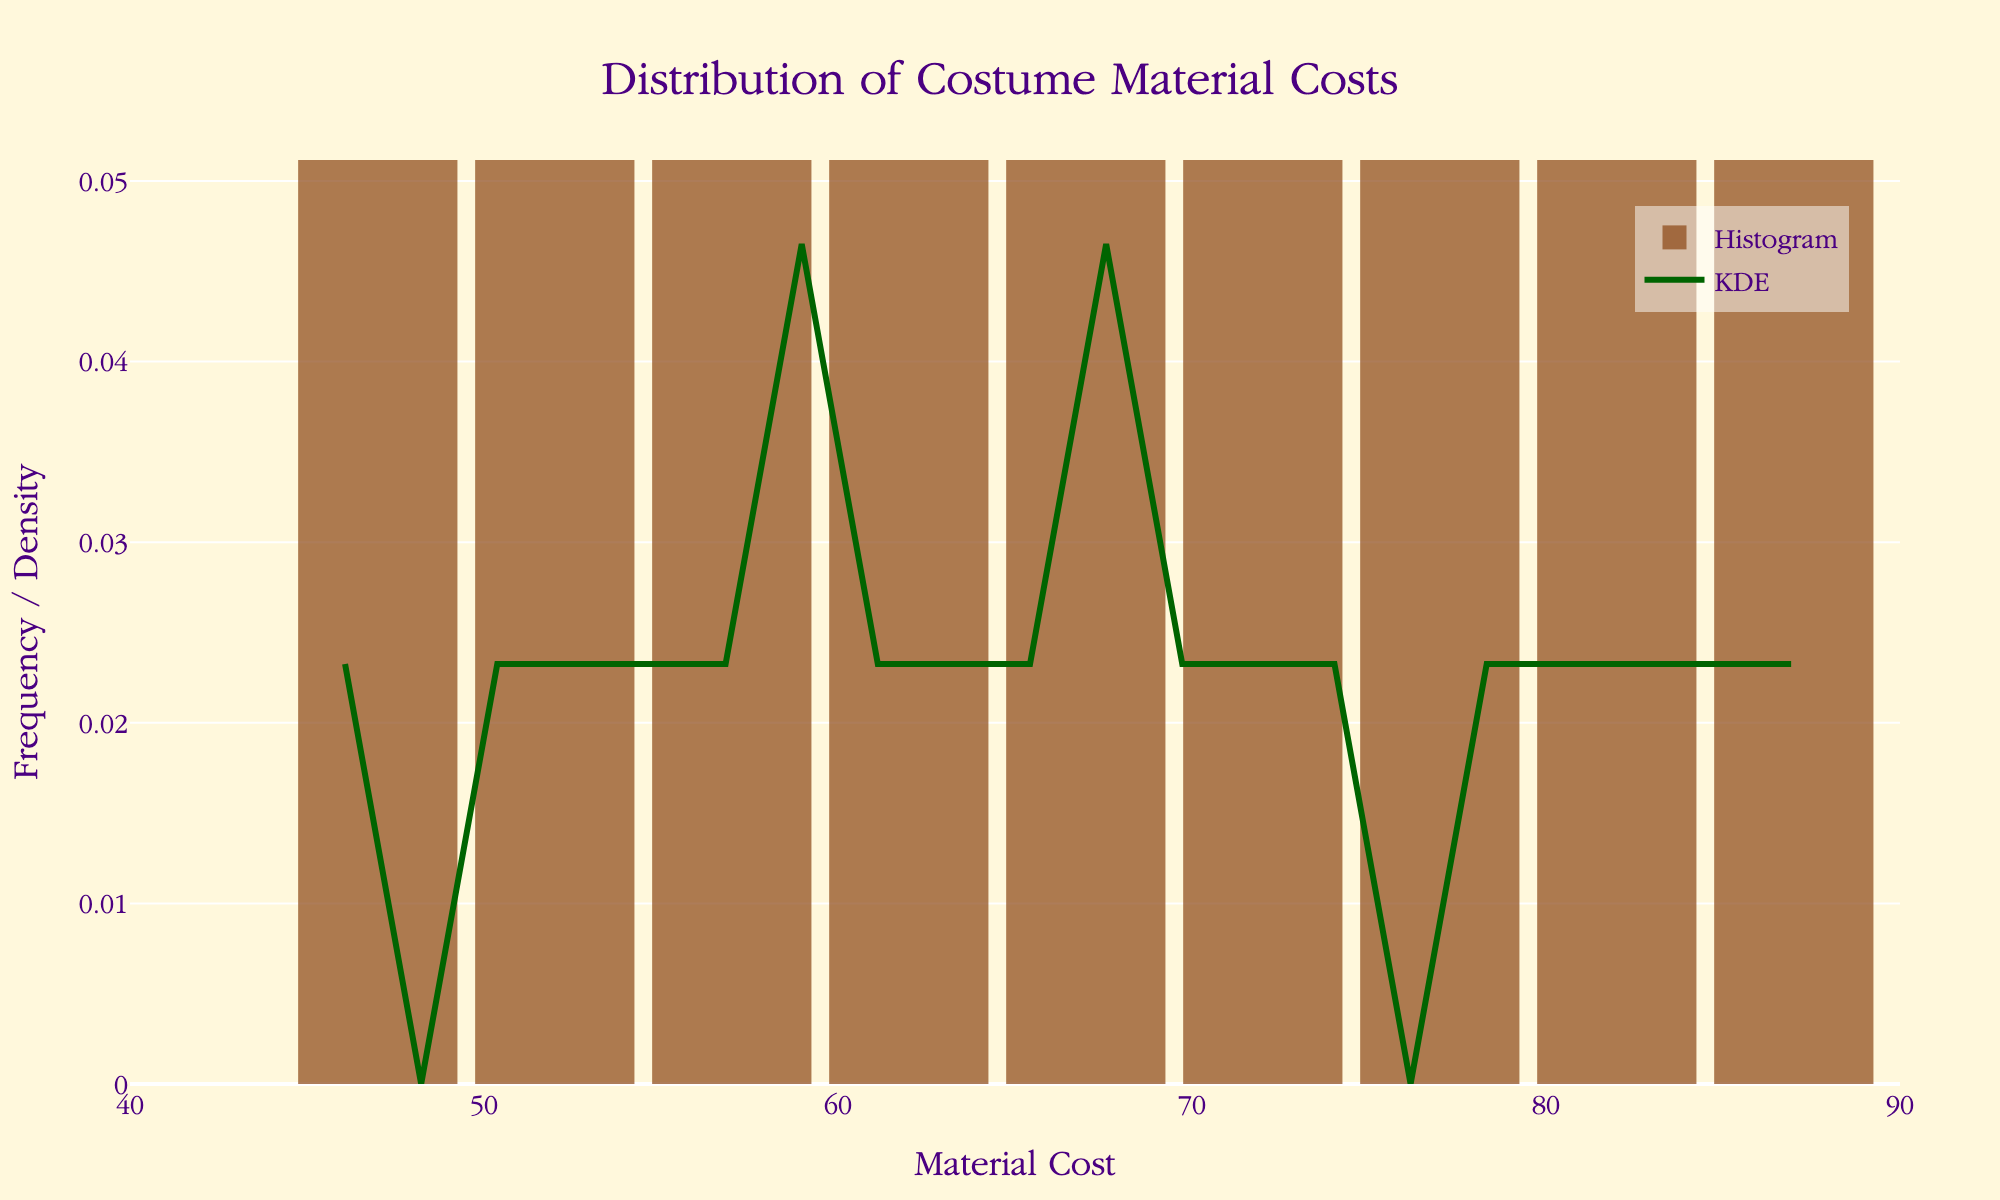What's the title of the figure? The title is located at the top of the figure and it describes what the figure is showing.
Answer: Distribution of Costume Material Costs What is the range of the x-axis (Material Cost)? The x-axis range can be observed by looking at the minimum and maximum values on the x-axis ticks.
Answer: 40 to 90 What color is the KDE curve line? The color of the KDE curve line can be identified by looking at the line itself on the plot.
Answer: Dark green Which historical period has the highest material cost in the dataset? To determine this, find the highest point (value) on the histogram and match it to the corresponding period from the data.
Answer: Rococo Does the KDE curve show any peaks, and if so, around what cost value(s)? To find peaks, observe the KDE curve and identify any prominent points where the curve rises and then falls.
Answer: Around 65 and 75 What is the approximate cost range with the highest frequency? The histogram bars represent frequency, so find the height of the bars that are the tallest and determine their range.
Answer: 60 to 70 Are there any evident gaps or periods with very low material costs? Look for bars on the histogram that are significantly shorter or absent, indicating lower frequencies.
Answer: Below 50 and above 85 What is the main difference between the histogram and the KDE curve in the figure? The histogram shows the frequency of material cost ranges, while the KDE curve shows the density estimation over the same range.
Answer: Visual frequency vs. density estimation Is the distribution of material costs skewed or symmetrical according to the KDE curve? By observing the shape of the KDE curve, determine whether it is evenly distributed or skewed to one side.
Answer: Symmetrical with slight skew towards higher costs What is the average material cost suggested by the KDE curve? Identify the peak of the KDE curve, as this often suggests the average (mean) value in a normal distribution.
Answer: Around 65 